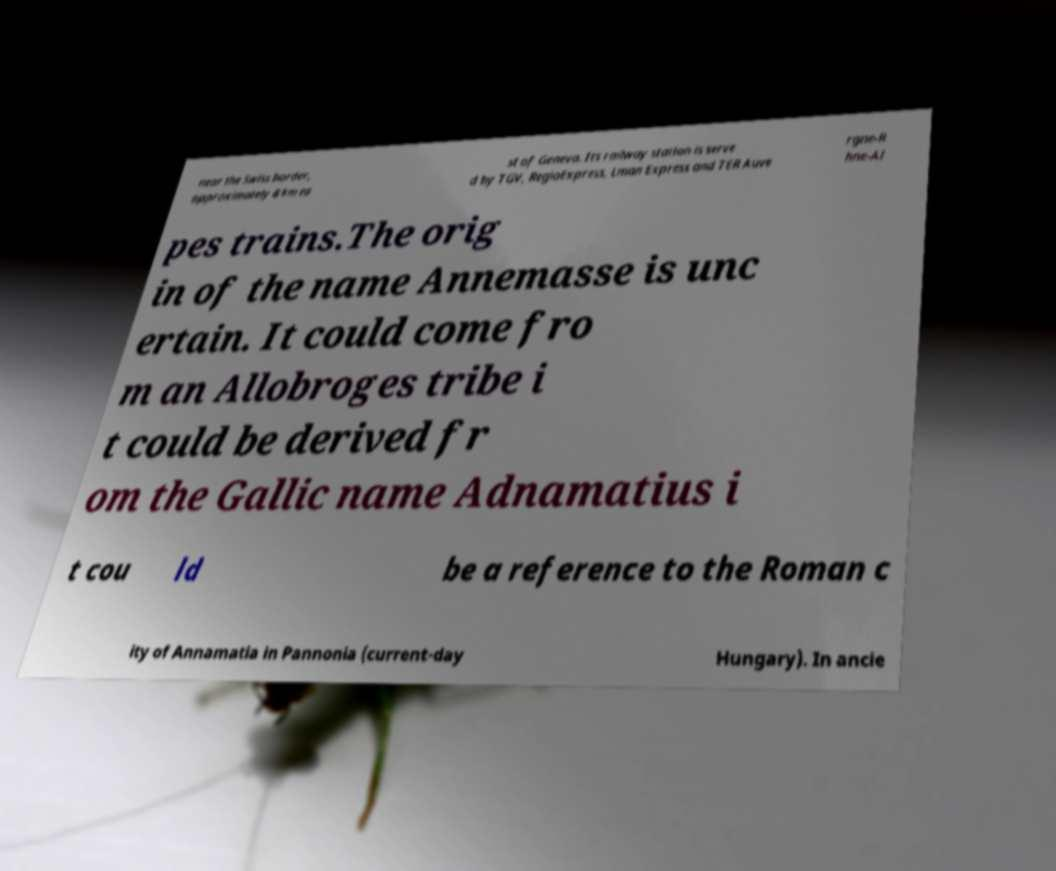Can you accurately transcribe the text from the provided image for me? near the Swiss border, approximately 8 km ea st of Geneva. Its railway station is serve d by TGV, RegioExpress, Lman Express and TER Auve rgne-R hne-Al pes trains.The orig in of the name Annemasse is unc ertain. It could come fro m an Allobroges tribe i t could be derived fr om the Gallic name Adnamatius i t cou ld be a reference to the Roman c ity of Annamatia in Pannonia (current-day Hungary). In ancie 